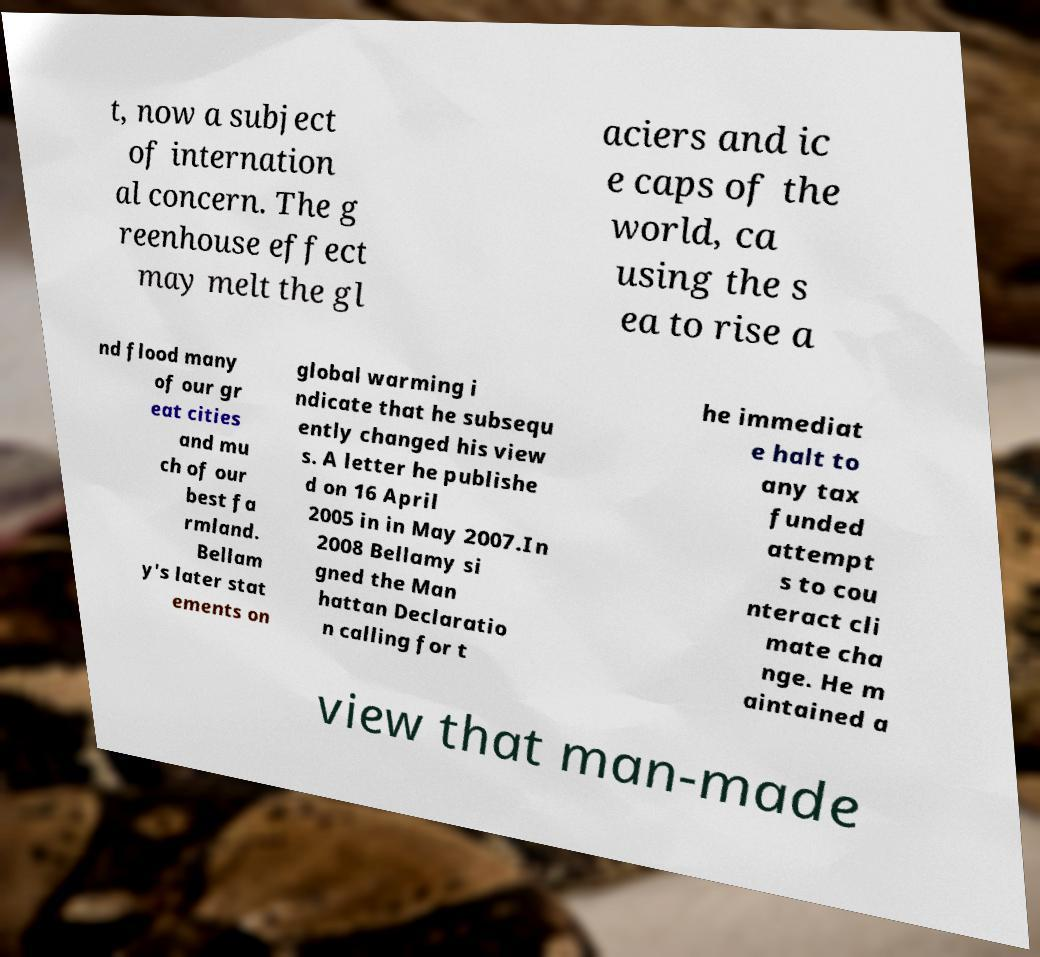What messages or text are displayed in this image? I need them in a readable, typed format. t, now a subject of internation al concern. The g reenhouse effect may melt the gl aciers and ic e caps of the world, ca using the s ea to rise a nd flood many of our gr eat cities and mu ch of our best fa rmland. Bellam y's later stat ements on global warming i ndicate that he subsequ ently changed his view s. A letter he publishe d on 16 April 2005 in in May 2007.In 2008 Bellamy si gned the Man hattan Declaratio n calling for t he immediat e halt to any tax funded attempt s to cou nteract cli mate cha nge. He m aintained a view that man-made 